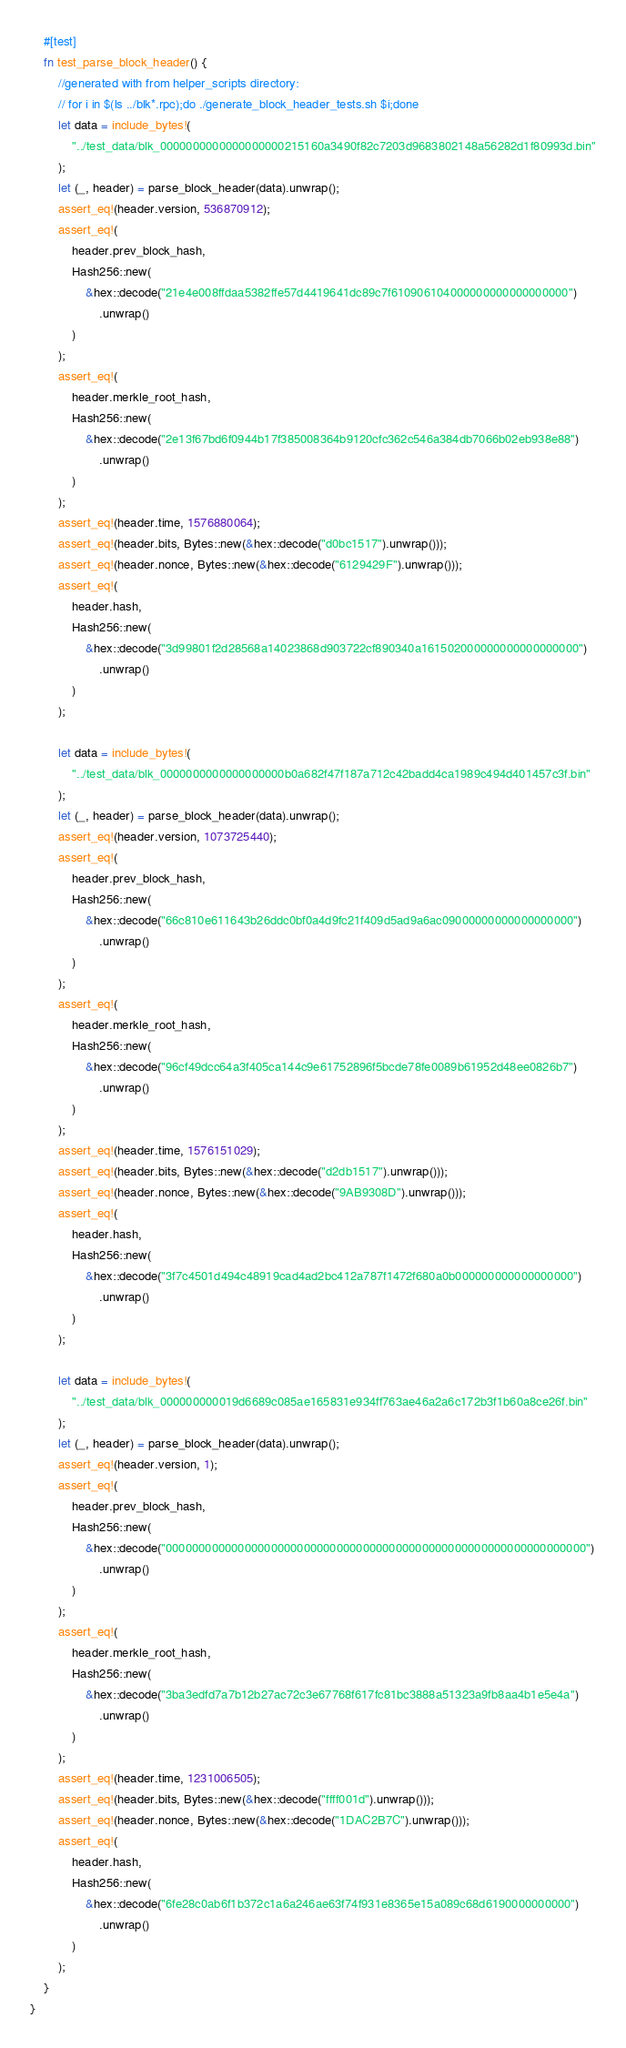Convert code to text. <code><loc_0><loc_0><loc_500><loc_500><_Rust_>    #[test]
    fn test_parse_block_header() {
        //generated with from helper_scripts directory:
        // for i in $(ls ../blk*.rpc);do ./generate_block_header_tests.sh $i;done
        let data = include_bytes!(
            "../test_data/blk_0000000000000000000215160a3490f82c7203d9683802148a56282d1f80993d.bin"
        );
        let (_, header) = parse_block_header(data).unwrap();
        assert_eq!(header.version, 536870912);
        assert_eq!(
            header.prev_block_hash,
            Hash256::new(
                &hex::decode("21e4e008ffdaa5382ffe57d4419641dc89c7f610906104000000000000000000")
                    .unwrap()
            )
        );
        assert_eq!(
            header.merkle_root_hash,
            Hash256::new(
                &hex::decode("2e13f67bd6f0944b17f385008364b9120cfc362c546a384db7066b02eb938e88")
                    .unwrap()
            )
        );
        assert_eq!(header.time, 1576880064);
        assert_eq!(header.bits, Bytes::new(&hex::decode("d0bc1517").unwrap()));
        assert_eq!(header.nonce, Bytes::new(&hex::decode("6129429F").unwrap()));
        assert_eq!(
            header.hash,
            Hash256::new(
                &hex::decode("3d99801f2d28568a14023868d903722cf890340a161502000000000000000000")
                    .unwrap()
            )
        );

        let data = include_bytes!(
            "../test_data/blk_0000000000000000000b0a682f47f187a712c42badd4ca1989c494d401457c3f.bin"
        );
        let (_, header) = parse_block_header(data).unwrap();
        assert_eq!(header.version, 1073725440);
        assert_eq!(
            header.prev_block_hash,
            Hash256::new(
                &hex::decode("66c810e611643b26ddc0bf0a4d9fc21f409d5ad9a6ac09000000000000000000")
                    .unwrap()
            )
        );
        assert_eq!(
            header.merkle_root_hash,
            Hash256::new(
                &hex::decode("96cf49dcc64a3f405ca144c9e61752896f5bcde78fe0089b61952d48ee0826b7")
                    .unwrap()
            )
        );
        assert_eq!(header.time, 1576151029);
        assert_eq!(header.bits, Bytes::new(&hex::decode("d2db1517").unwrap()));
        assert_eq!(header.nonce, Bytes::new(&hex::decode("9AB9308D").unwrap()));
        assert_eq!(
            header.hash,
            Hash256::new(
                &hex::decode("3f7c4501d494c48919cad4ad2bc412a787f1472f680a0b000000000000000000")
                    .unwrap()
            )
        );

        let data = include_bytes!(
            "../test_data/blk_000000000019d6689c085ae165831e934ff763ae46a2a6c172b3f1b60a8ce26f.bin"
        );
        let (_, header) = parse_block_header(data).unwrap();
        assert_eq!(header.version, 1);
        assert_eq!(
            header.prev_block_hash,
            Hash256::new(
                &hex::decode("0000000000000000000000000000000000000000000000000000000000000000")
                    .unwrap()
            )
        );
        assert_eq!(
            header.merkle_root_hash,
            Hash256::new(
                &hex::decode("3ba3edfd7a7b12b27ac72c3e67768f617fc81bc3888a51323a9fb8aa4b1e5e4a")
                    .unwrap()
            )
        );
        assert_eq!(header.time, 1231006505);
        assert_eq!(header.bits, Bytes::new(&hex::decode("ffff001d").unwrap()));
        assert_eq!(header.nonce, Bytes::new(&hex::decode("1DAC2B7C").unwrap()));
        assert_eq!(
            header.hash,
            Hash256::new(
                &hex::decode("6fe28c0ab6f1b372c1a6a246ae63f74f931e8365e15a089c68d6190000000000")
                    .unwrap()
            )
        );
    }
}
</code> 